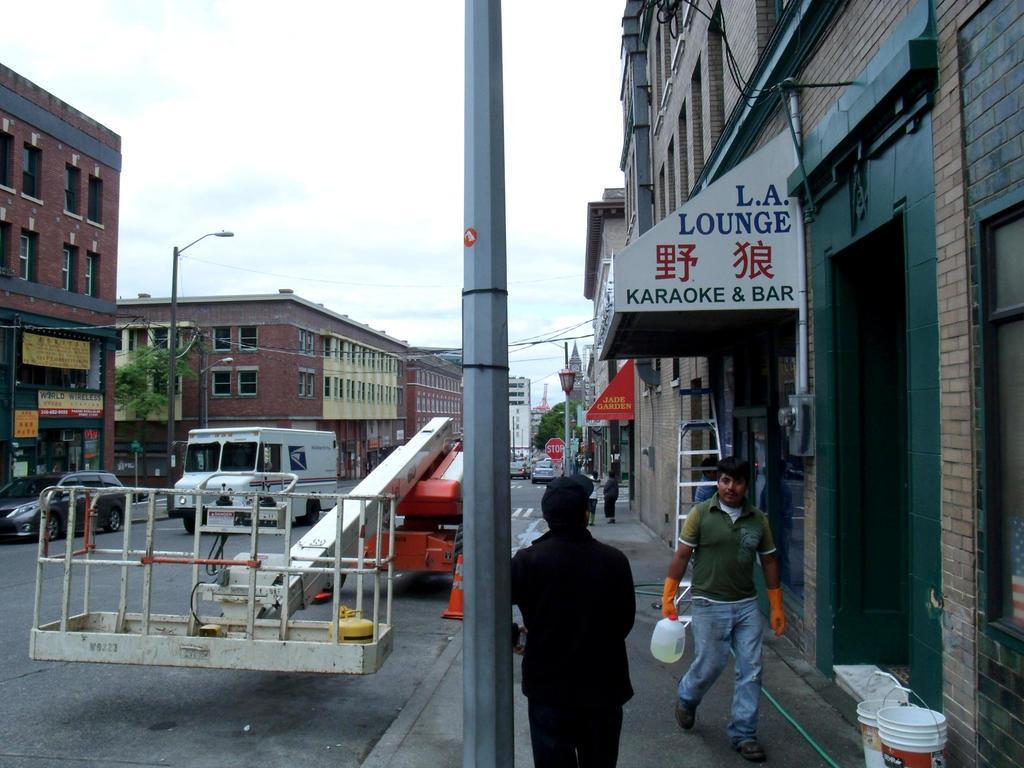Can you describe this image briefly? In this image I can see two persons, one person is standing and the other person is walking on the pathway holding a bottle. Background I can see few vehicles, buildings in brown color, trees in green color and sky in white color. 